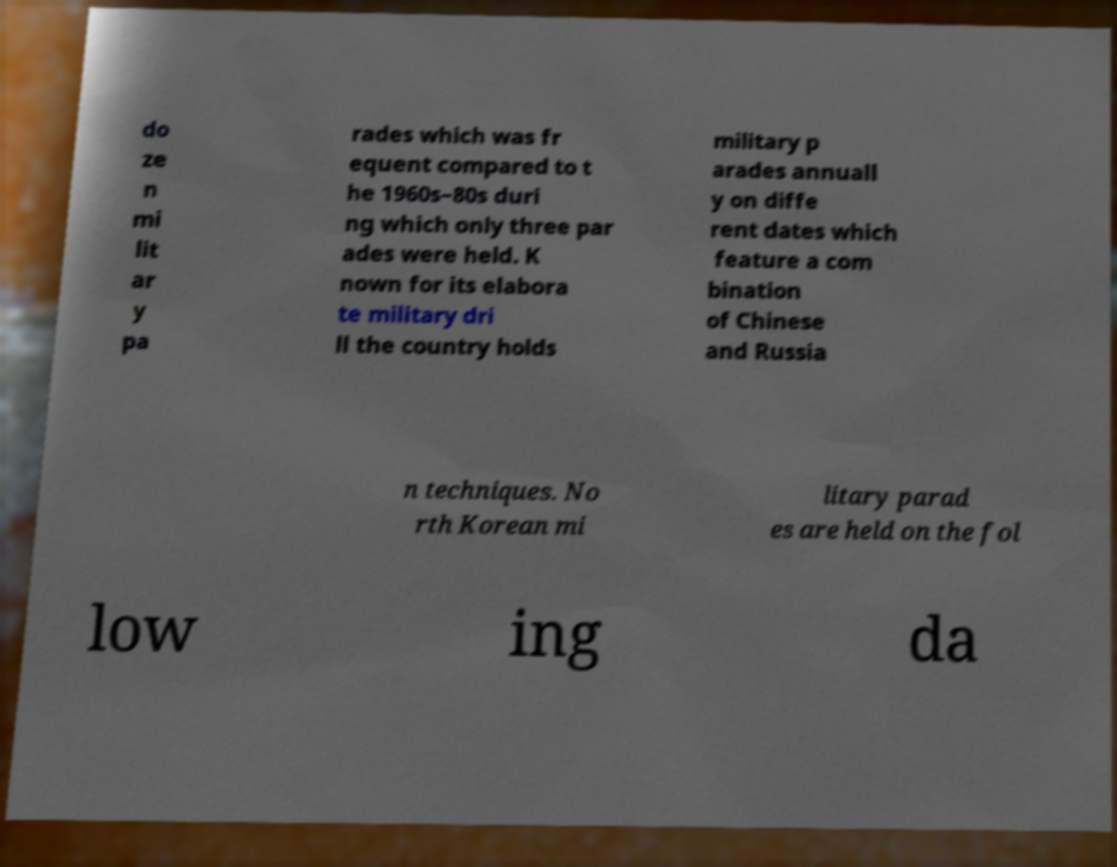What messages or text are displayed in this image? I need them in a readable, typed format. do ze n mi lit ar y pa rades which was fr equent compared to t he 1960s–80s duri ng which only three par ades were held. K nown for its elabora te military dri ll the country holds military p arades annuall y on diffe rent dates which feature a com bination of Chinese and Russia n techniques. No rth Korean mi litary parad es are held on the fol low ing da 